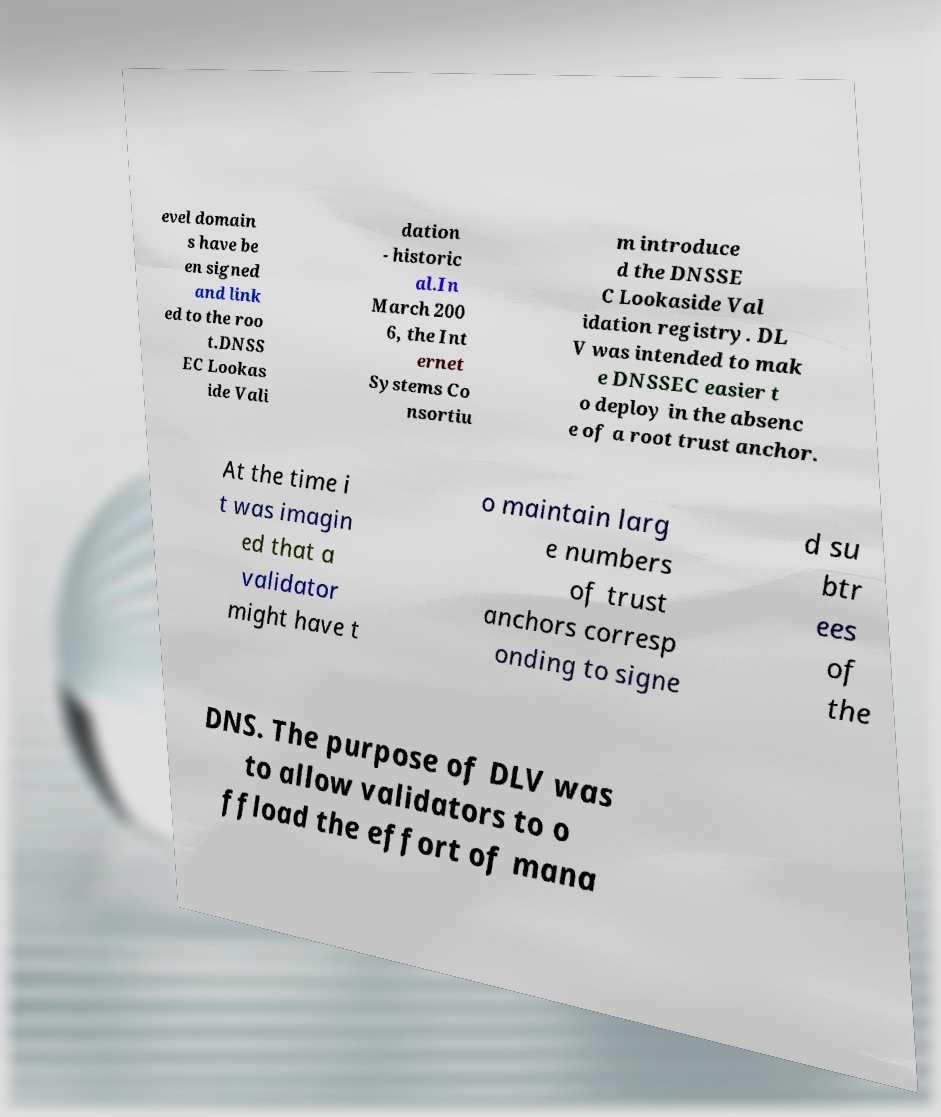What messages or text are displayed in this image? I need them in a readable, typed format. evel domain s have be en signed and link ed to the roo t.DNSS EC Lookas ide Vali dation - historic al.In March 200 6, the Int ernet Systems Co nsortiu m introduce d the DNSSE C Lookaside Val idation registry. DL V was intended to mak e DNSSEC easier t o deploy in the absenc e of a root trust anchor. At the time i t was imagin ed that a validator might have t o maintain larg e numbers of trust anchors corresp onding to signe d su btr ees of the DNS. The purpose of DLV was to allow validators to o ffload the effort of mana 